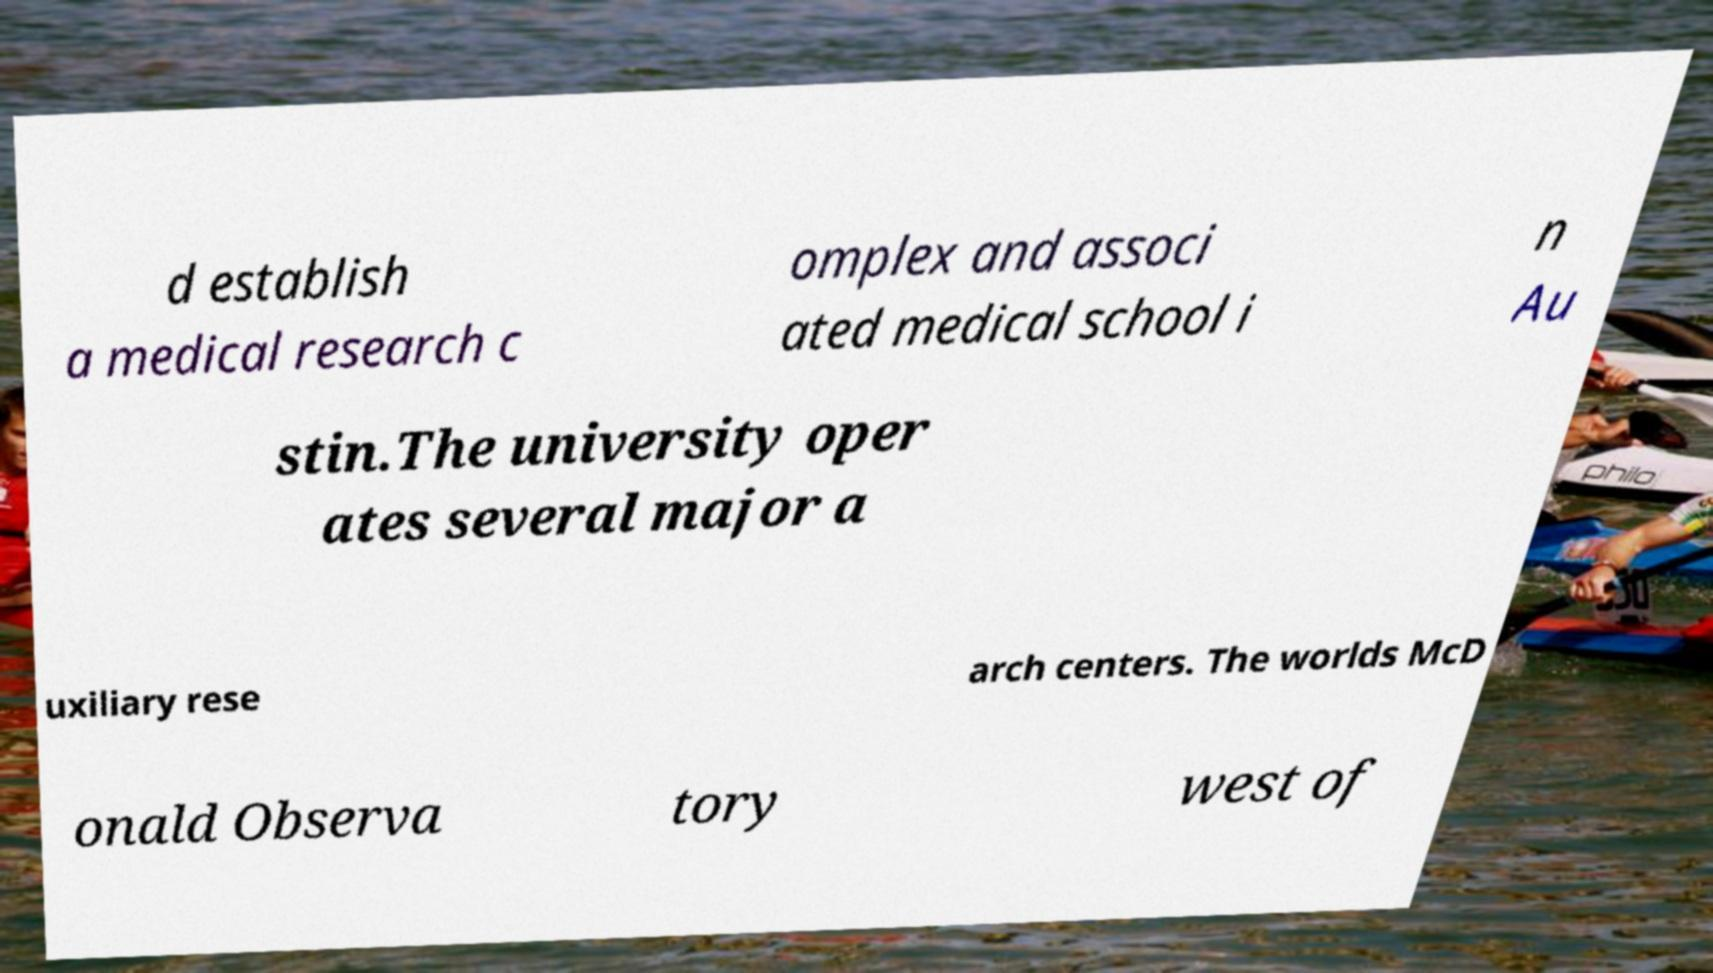I need the written content from this picture converted into text. Can you do that? d establish a medical research c omplex and associ ated medical school i n Au stin.The university oper ates several major a uxiliary rese arch centers. The worlds McD onald Observa tory west of 